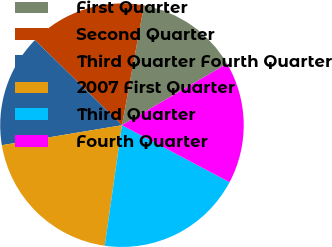<chart> <loc_0><loc_0><loc_500><loc_500><pie_chart><fcel>First Quarter<fcel>Second Quarter<fcel>Third Quarter Fourth Quarter<fcel>2007 First Quarter<fcel>Third Quarter<fcel>Fourth Quarter<nl><fcel>13.67%<fcel>15.57%<fcel>14.95%<fcel>20.12%<fcel>19.51%<fcel>16.18%<nl></chart> 